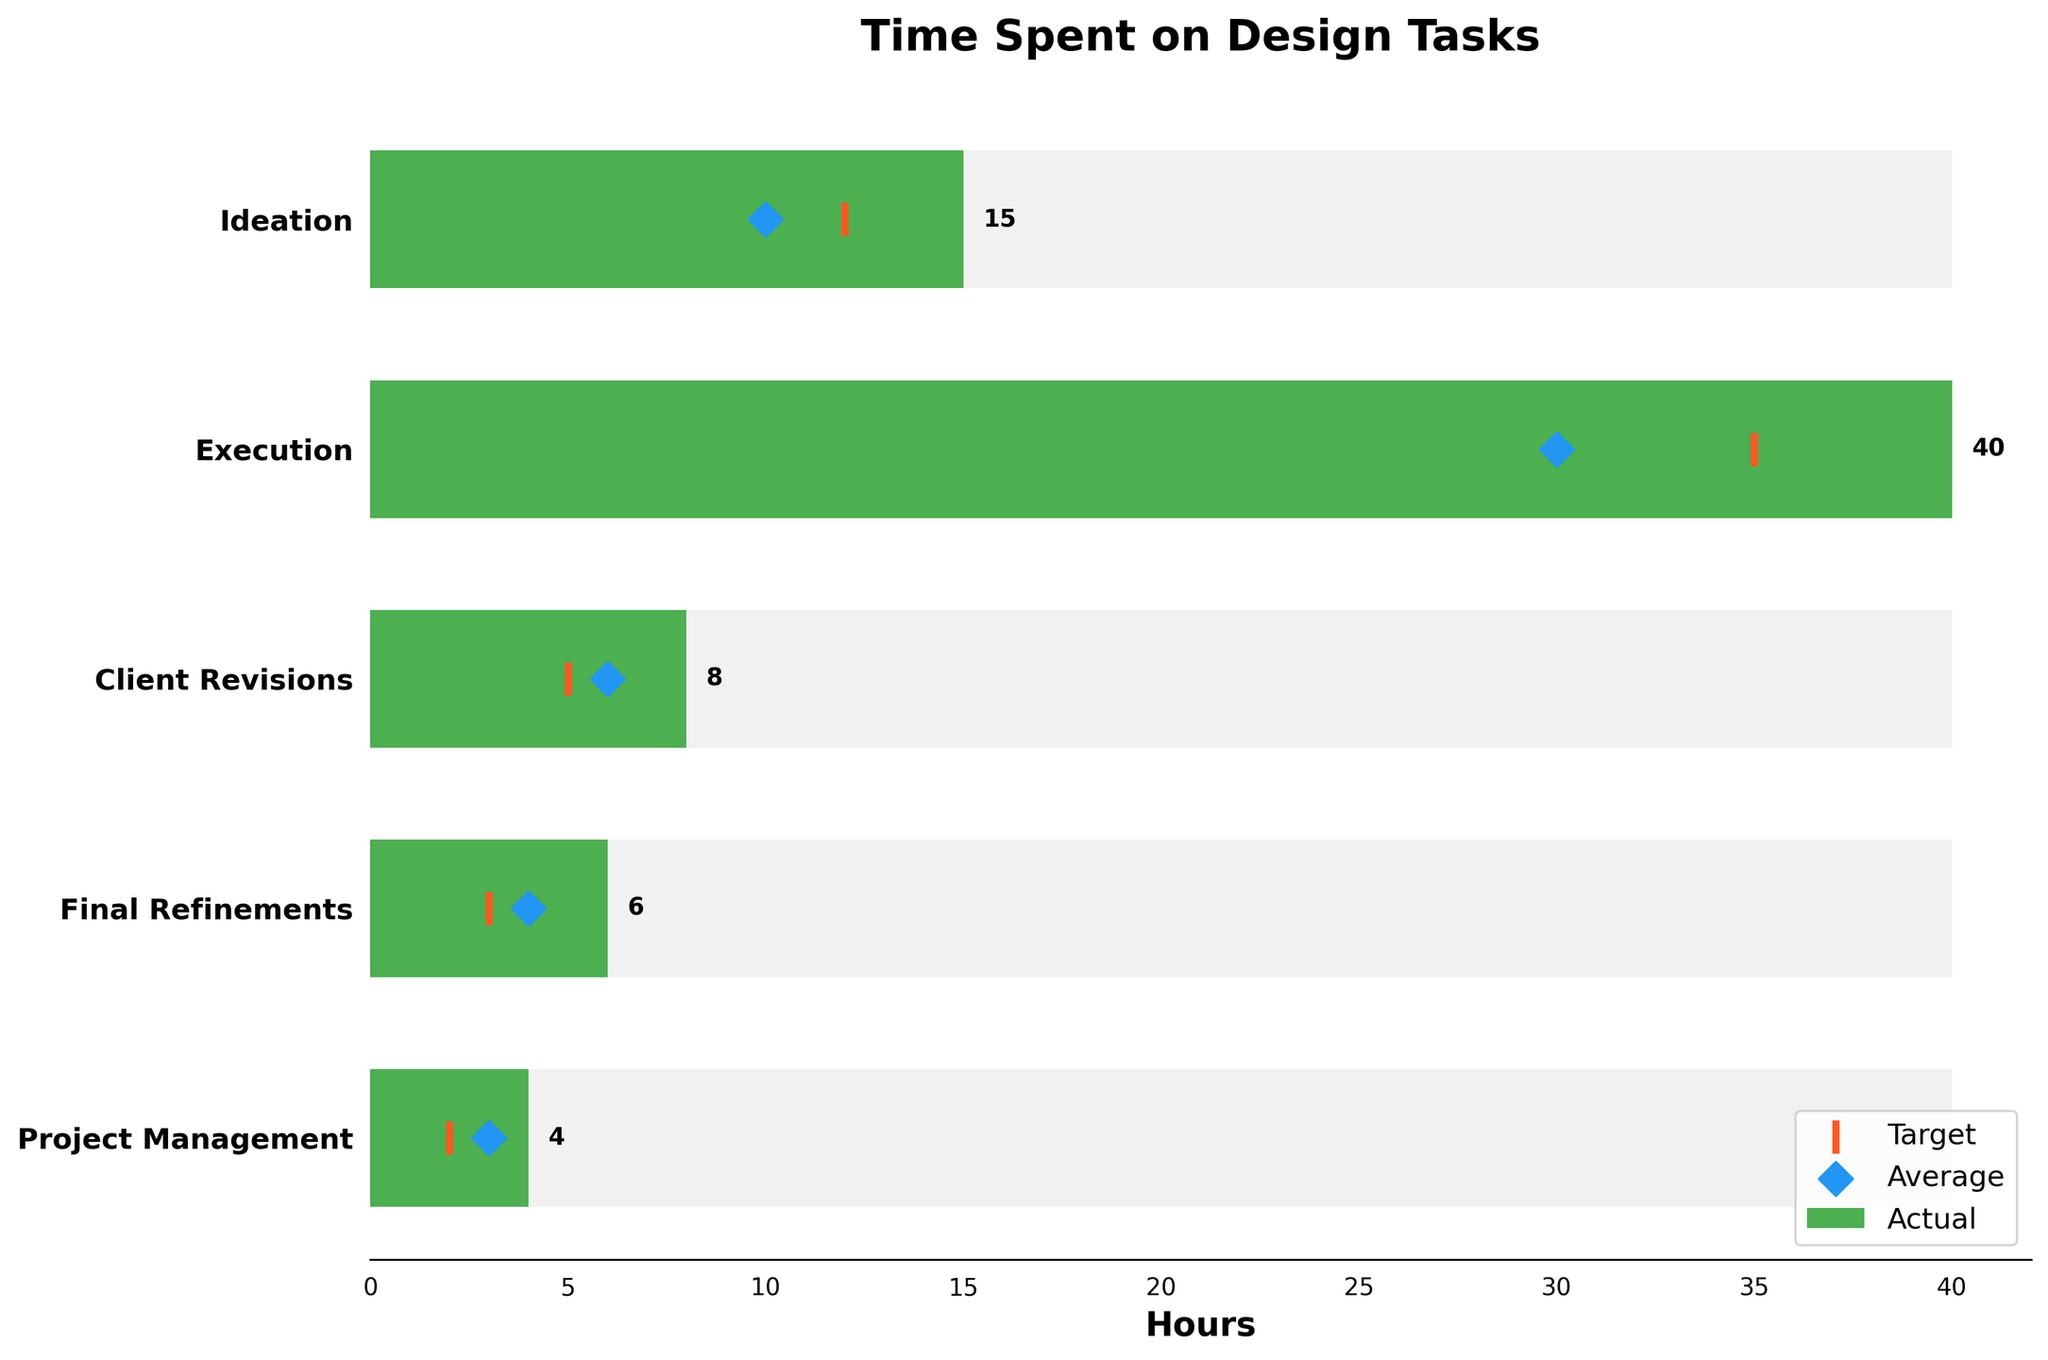What is the title of the chart? The title is written at the top of the chart and gives an overview of what the figure represents. By looking at the top, you can see that the title is "Time Spent on Design Tasks."
Answer: Time Spent on Design Tasks Which design task took the most time in Actual hours? By looking at the length of the green bars, you can see that the task "Execution" represents the longest bar. From the figure, the "Actual hours" for "Execution" is 40.
Answer: Execution What are the target hours for the task "Client Revisions"? The target hours for each task are represented by orange markers on the horizontal axis. By referring to the figure, you can find that the target hours for "Client Revisions" is marked at 5 hours.
Answer: 5 How much more time was spent on "Ideation" than the target hours? To determine the extra time spent on "Ideation", subtract the target hours from the actual hours. The actual hours for "Ideation" is 15 and the target hours is 12. So, 15 - 12 = 3 hours more spent.
Answer: 3 Which task exceeded its target by the largest margin? To find this out, calculate the difference between actual and target hours for each task, and see which has the largest positive difference. The differences are as follows: 
Ideation: 15-12=3,
Execution: 40-35=5,
Client Revisions: 8-5=3,
Final Refinements: 6-3=3,
Project Management: 4-2=2.
The largest margin is 5 hours for "Execution."
Answer: Execution How much time, in total, would have been saved if all tasks had only met their target hours? Subtract the target hours from the actual hours for each task and sum them up. Total saved time is:
(Ideation: 15-12=3) + (Execution: 40-35=5) + (Client Revisions: 8-5=3) + (Final Refinements: 6-3=3) + (Project Management: 4-2=2).
So, 3+5+3+3+2 = 16 hours saved.
Answer: 16 What is the average time spent on "Execution" across the three metrics (Actual, Target, and Average)? Add up the three metrics for "Execution" and divide by 3. So, (40 + 35 + 30) / 3 = 105 / 3 = 35 hours for the average.
Answer: 35 Which tasks have actual hours that are greater than both their Target and Average hours? Check each task’s actual hours and see if it exceeds both its target and average hours. The tasks with actual hours greater than both target and average are "Ideation", "Execution", "Client Revisions", and "Final Refinements".
Answer: Ideation, Execution, Client Revisions, Final Refinements 